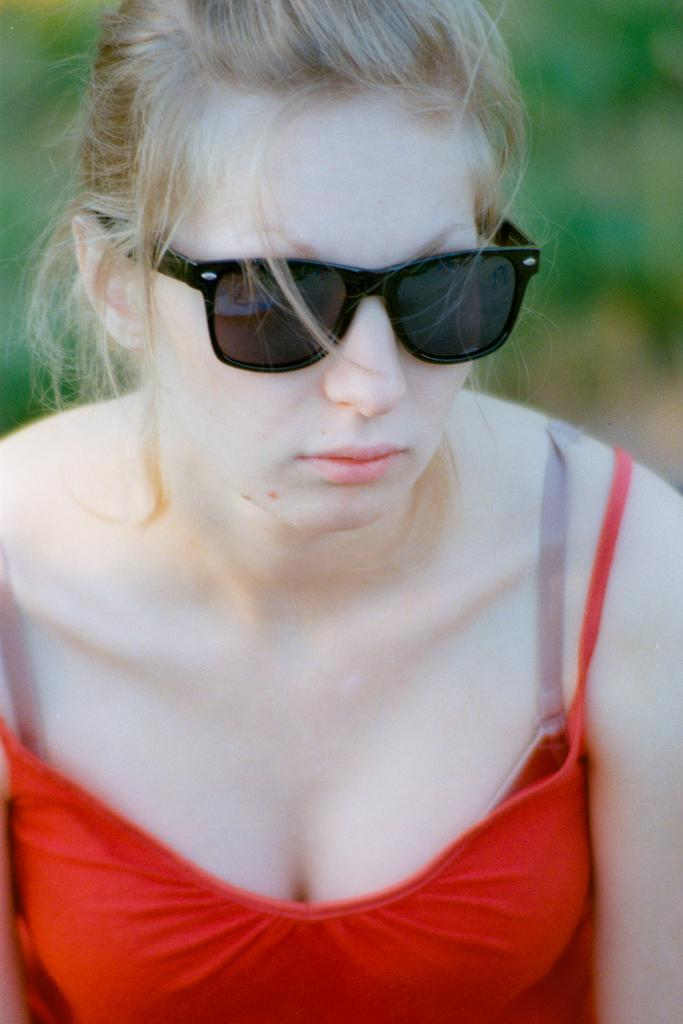Who is the main subject in the image? There is a lady in the image. What is the lady wearing in the image? The lady is wearing a red dress and sunglasses. What grade did the lady receive in the image? There is no indication of any grades or academic achievements in the image. 